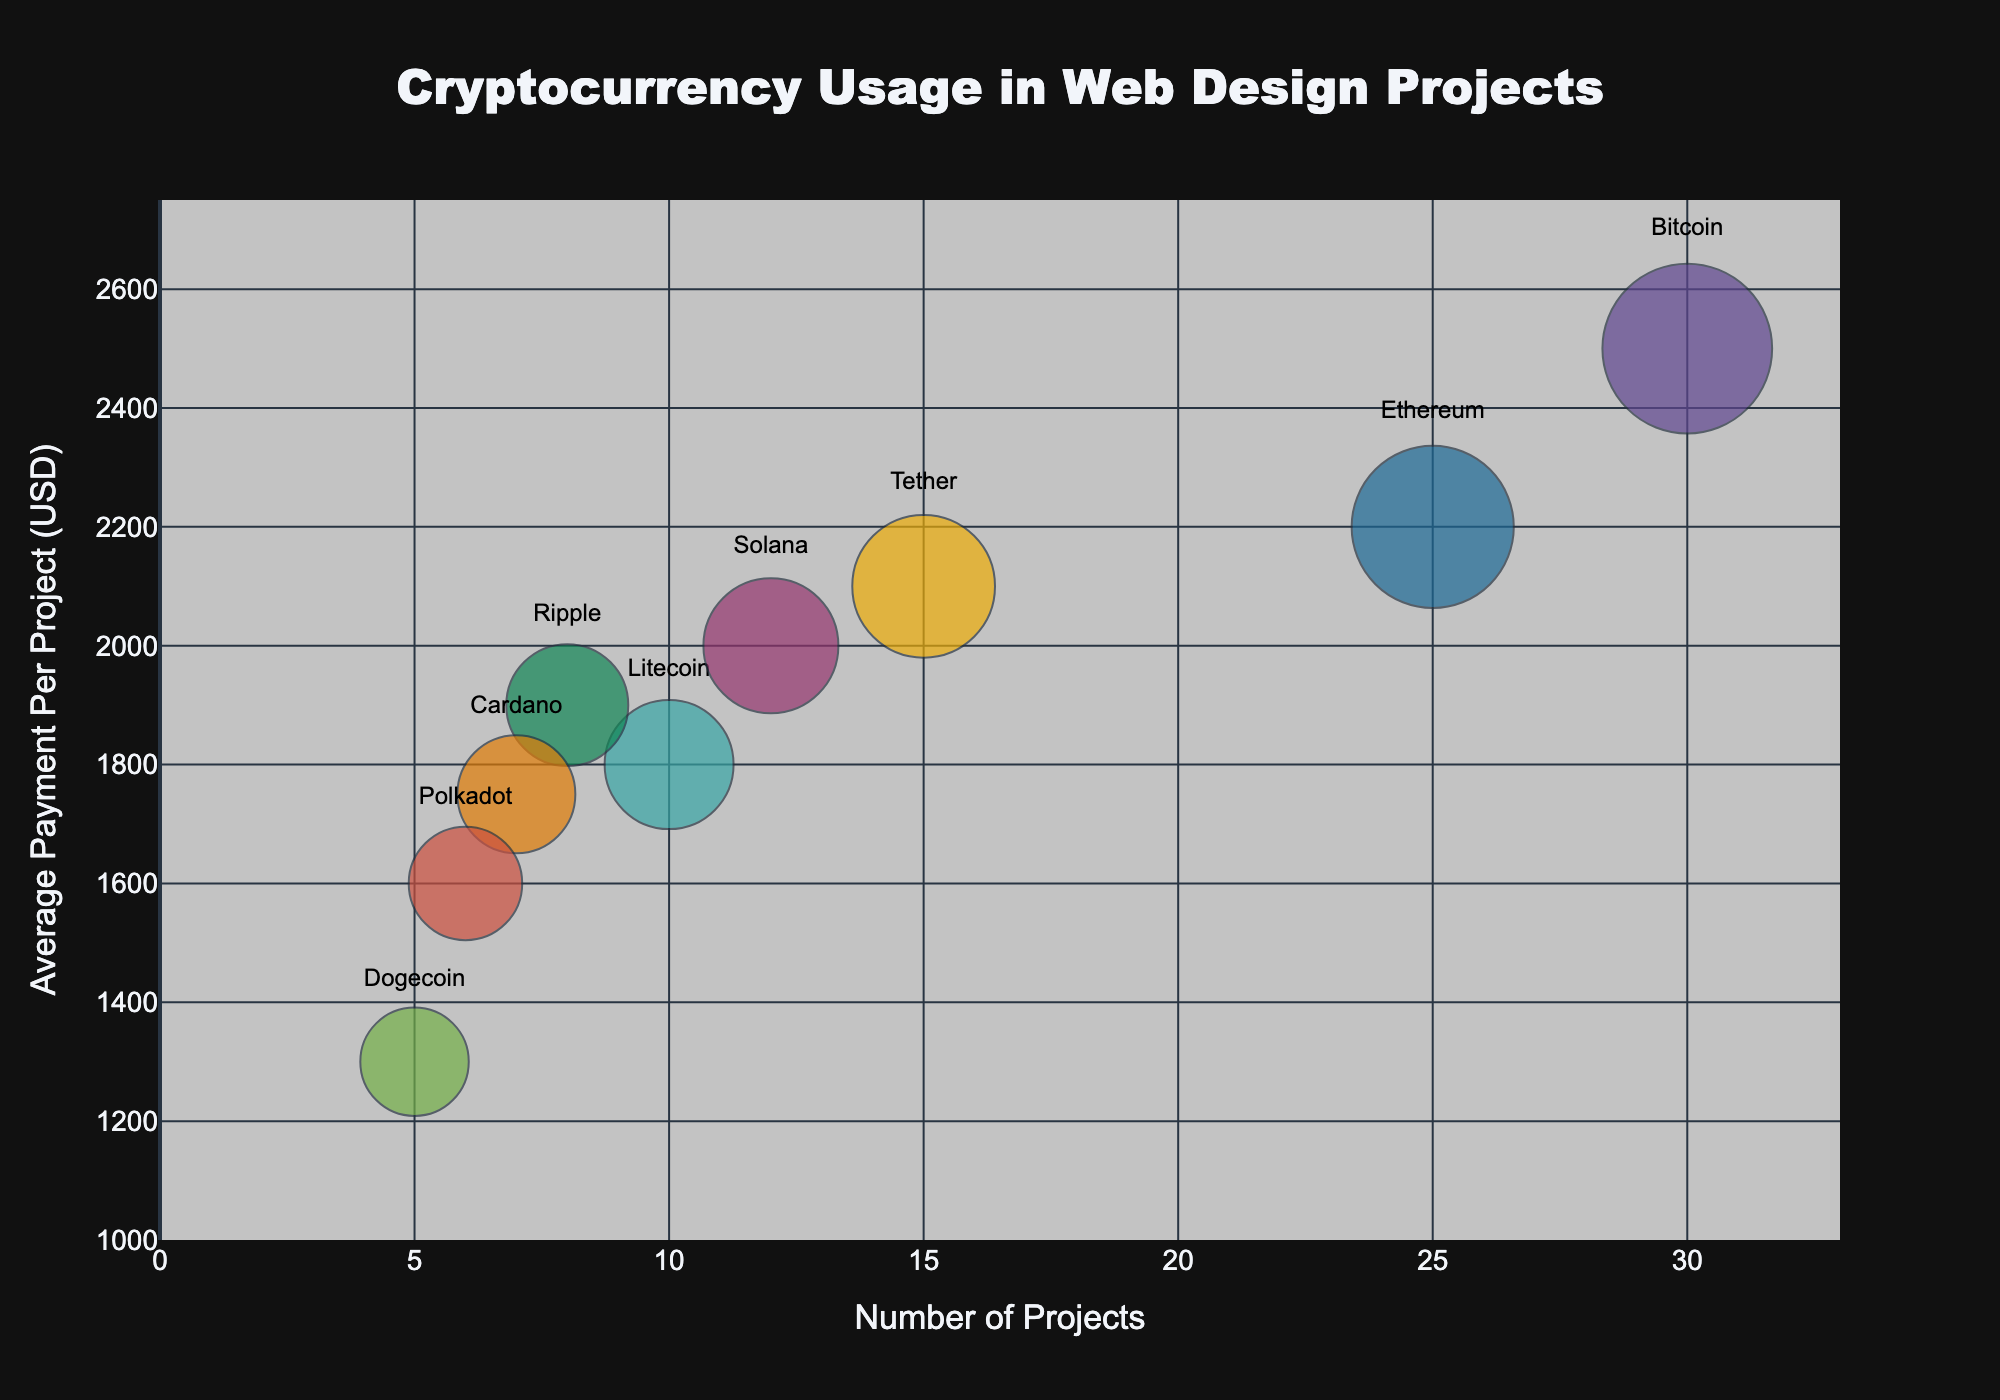What's the title of the chart? The title of the chart is located at the top and it provides a brief description of the chart's content. By looking at the figure, we see it is "Cryptocurrency Usage in Web Design Projects".
Answer: Cryptocurrency Usage in Web Design Projects How many cryptocurrency coins are represented in the chart? The chart uses different colors to represent each cryptocurrency coin. By counting the unique colors and labels, we see there are nine different coins.
Answer: Nine Which cryptocurrency has the highest number of projects? By examining the x-axis, which represents the number of projects, the cryptocurrency with the farthest bubble to the right gives the highest number. The bubble for Bitcoin is the farthest to the right on the x-axis.
Answer: Bitcoin What's the average payment per project for Dogecoin? By locating Dogecoin on the chart and referring to its position on the y-axis, we see that Dogecoin's average payment per project is approximately 1300 USD.
Answer: 1300 USD Which cryptocurrency has the smallest bubble size? The size of the bubbles is based on the number of projects. The smallest bubble on the chart corresponds to Dogecoin, indicating it has the fewest projects.
Answer: Dogecoin What is the combined number of projects for Litecoin and Cardano? By looking at Litecoin's and Cardano's positions along the x-axis, we see that Litecoin has 10 projects and Cardano has 7 projects. Summing these, we get 10 + 7 = 17 projects.
Answer: 17 projects How does the average payment for Ethereum compare to that of Solana? Referring to their positions on the y-axis, Ethereum is slightly higher than Solana. Ethereum's average payment per project is 2200 USD, while Solana's is 2000 USD.
Answer: Ethereum's average payment is higher by 200 USD What is the total average payment for Ripple and Tether combined? Ripple's average payment is 1900 USD, and Tether's is 2100 USD. Adding these together, we get 1900 + 2100 = 4000 USD.
Answer: 4000 USD Which cryptocurrency has the highest average payment per project? The highest point on the y-axis shows the average payment per project. Bitcoin has the highest average payment, which is 2500 USD.
Answer: Bitcoin Are there more projects completed using Tether or Polkadot? By comparing the x-axis positions, Tether's bubble is farther right than Polkadot's. Thus, Tether has more projects.
Answer: Tether 